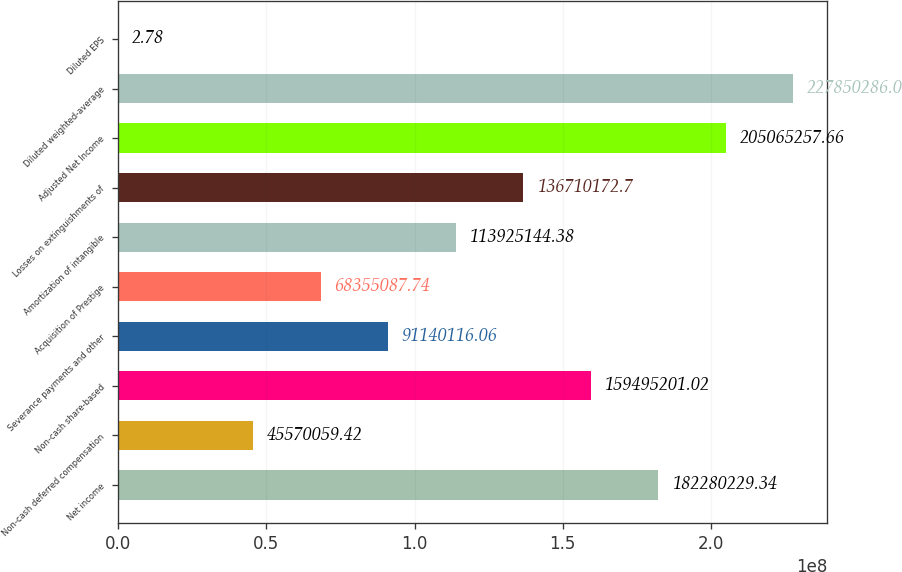Convert chart. <chart><loc_0><loc_0><loc_500><loc_500><bar_chart><fcel>Net income<fcel>Non-cash deferred compensation<fcel>Non-cash share-based<fcel>Severance payments and other<fcel>Acquisition of Prestige<fcel>Amortization of intangible<fcel>Losses on extinguishments of<fcel>Adjusted Net Income<fcel>Diluted weighted-average<fcel>Diluted EPS<nl><fcel>1.8228e+08<fcel>4.55701e+07<fcel>1.59495e+08<fcel>9.11401e+07<fcel>6.83551e+07<fcel>1.13925e+08<fcel>1.3671e+08<fcel>2.05065e+08<fcel>2.2785e+08<fcel>2.78<nl></chart> 